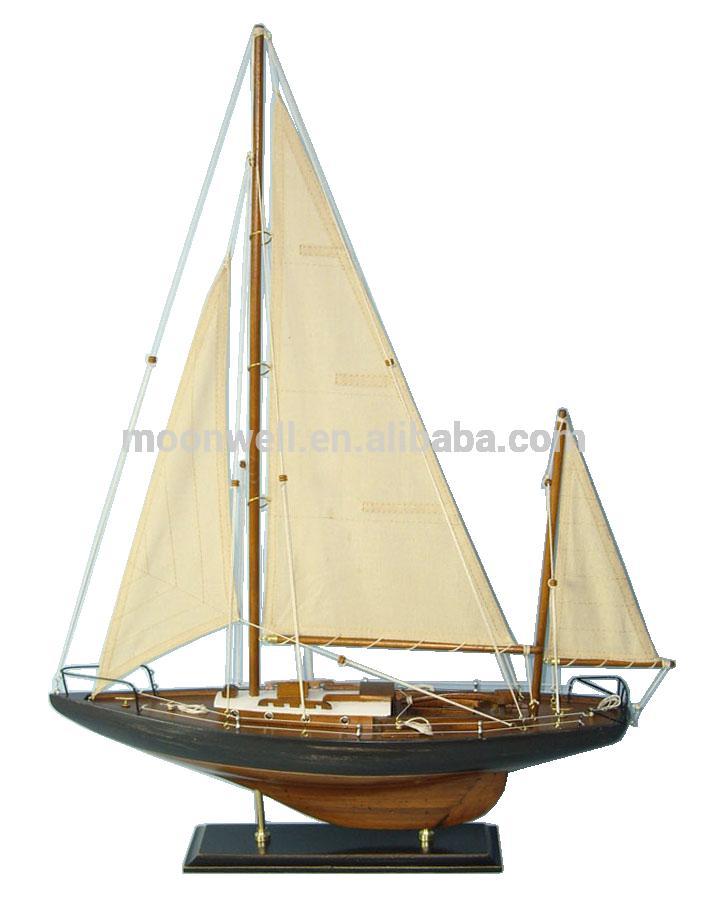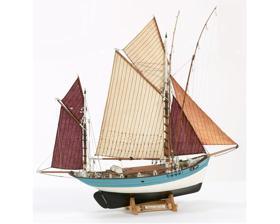The first image is the image on the left, the second image is the image on the right. Assess this claim about the two images: "Right image features a boat with only brown sails.". Correct or not? Answer yes or no. No. 